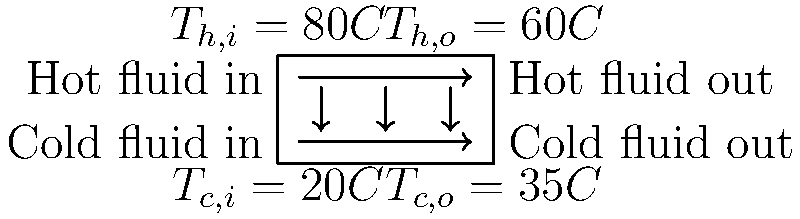In a cross-flow heat exchanger used for cooling a community center's HVAC system, hot air enters at 80°C and exits at 60°C, while cold water enters at 20°C and exits at 35°C. If the specific heat capacity of air is 1.005 kJ/(kg·K) and the mass flow rate of air is 2 kg/s, calculate the rate of heat transfer in the heat exchanger. How might this information be relevant to improving energy efficiency in public buildings? Let's approach this step-by-step:

1) The rate of heat transfer can be calculated using the equation:
   $$Q = \dot{m}_h c_{p,h} (T_{h,i} - T_{h,o})$$
   
   Where:
   $Q$ = rate of heat transfer
   $\dot{m}_h$ = mass flow rate of hot fluid (air)
   $c_{p,h}$ = specific heat capacity of hot fluid (air)
   $T_{h,i}$ = inlet temperature of hot fluid
   $T_{h,o}$ = outlet temperature of hot fluid

2) We have the following data:
   $\dot{m}_h = 2$ kg/s
   $c_{p,h} = 1.005$ kJ/(kg·K)
   $T_{h,i} = 80°C = 353.15$ K
   $T_{h,o} = 60°C = 333.15$ K

3) Plugging these values into the equation:
   $$Q = 2 \times 1.005 \times (353.15 - 333.15)$$
   $$Q = 2 \times 1.005 \times 20$$
   $$Q = 40.2$$ kW

4) Therefore, the rate of heat transfer in the heat exchanger is 40.2 kW.

This information is relevant to improving energy efficiency in public buildings because:
- It helps in sizing HVAC systems appropriately.
- It allows for optimization of heat recovery systems.
- It can be used to estimate energy savings from implementing such systems.
- It provides data for cost-benefit analysis of energy-efficient technologies.
Answer: 40.2 kW 